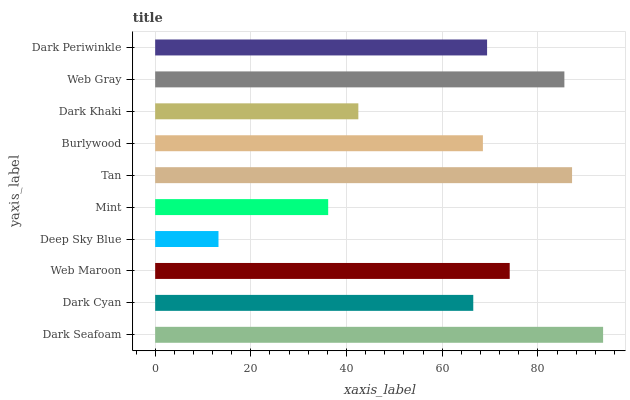Is Deep Sky Blue the minimum?
Answer yes or no. Yes. Is Dark Seafoam the maximum?
Answer yes or no. Yes. Is Dark Cyan the minimum?
Answer yes or no. No. Is Dark Cyan the maximum?
Answer yes or no. No. Is Dark Seafoam greater than Dark Cyan?
Answer yes or no. Yes. Is Dark Cyan less than Dark Seafoam?
Answer yes or no. Yes. Is Dark Cyan greater than Dark Seafoam?
Answer yes or no. No. Is Dark Seafoam less than Dark Cyan?
Answer yes or no. No. Is Dark Periwinkle the high median?
Answer yes or no. Yes. Is Burlywood the low median?
Answer yes or no. Yes. Is Dark Cyan the high median?
Answer yes or no. No. Is Web Gray the low median?
Answer yes or no. No. 